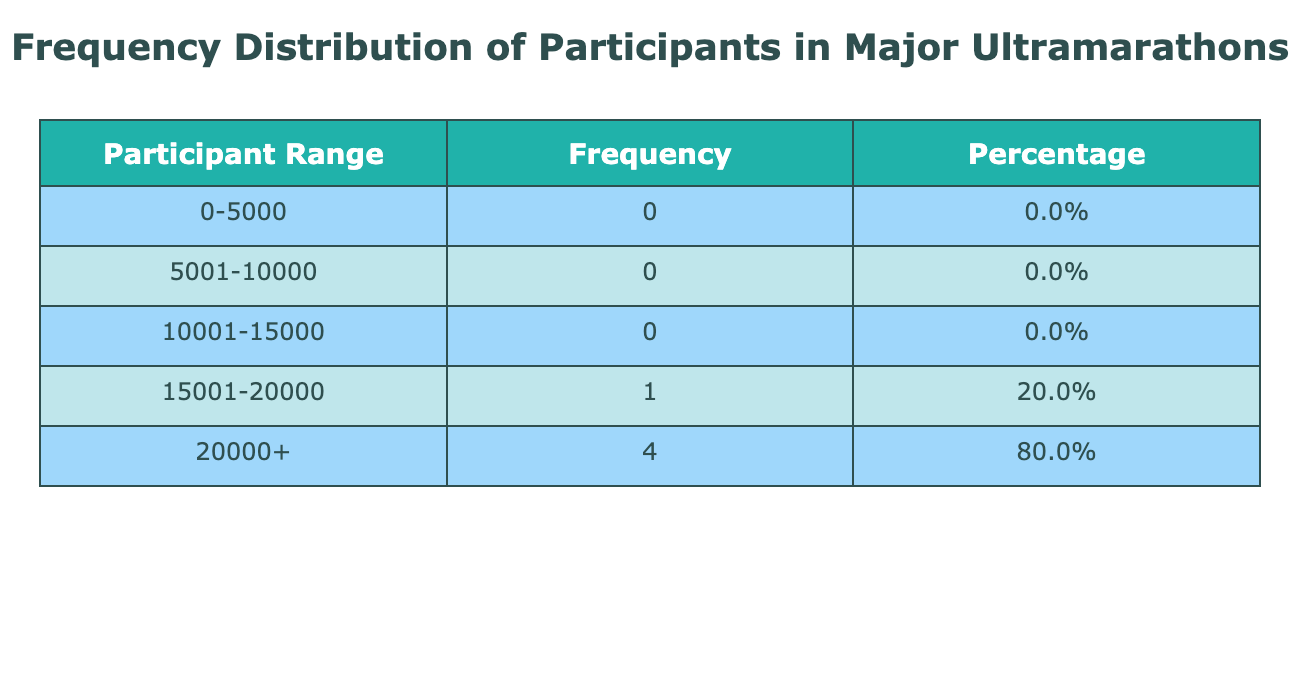What was the range with the highest number of participants? From the table, we see the frequency counts for the participant ranges. The highest frequency corresponds to the '15001-20000' range, which has the highest count.
Answer: 15001-20000 How many events had participants in the range of 0-5000? By examining the frequency distribution, we see that only the year 2020 has all four events with 0 participants, which falls into this range. Therefore, there is only one event in this category.
Answer: 1 What was the total number of participants across all events in 2019? The total participants for 2019 can be obtained by summing the individual participants from each event: 3000 (Ultra-Trail du Mont-Blanc) + 400 (Western States Endurance Run) + 20000 (Comrades Marathon) + 800 (The North Face Endurance Challenge) = 24100. Hence the total is 24100 participants.
Answer: 24100 Is there any year where the participant number for Western States Endurance Run was higher than 500? Looking at the table data, the years 2018, 2019, 2021, 2022, and 2023 have participant numbers for this event of 380, 400, 380, 420, and 450 respectively. None of these values exceeds 500. Hence, the answer is no.
Answer: No What was the average number of participants for the Comrades Marathon over the years? To calculate the average, we sum the participants over the years: 19000 (2018) + 20000 (2019) + 0 (2020) + 16000 (2021) + 18000 (2022) + 19000 (2023) = 112000. There are five data points (excluding 2020 as it has 0), giving an average of 112000/5 = 22400.
Answer: 22400 How many participant ranges are available in the distribution table? The table lists five distinct participant ranges: '0-5000', '5001-10000', '10001-15000', '15001-20000', and '20000+'. Counting these gives us a total of 5 ranges available.
Answer: 5 Which year had the least number of participants across all events combined? By calculating the total participants per year, we find that 2020 had 0 participants across all events. Thus, 2020 is the year with the least number of participants.
Answer: 2020 What percentage of events had more than 15000 participants? From the table, the counts for the ranges show that only the '15001-20000' and '20000+' ranges are above 15000. In total, there are 3 events (Comrades Marathon in 2018, 2019, and 2022). Since there are 20 events overall, the percentage is (3/20) * 100 = 15%.
Answer: 15% 